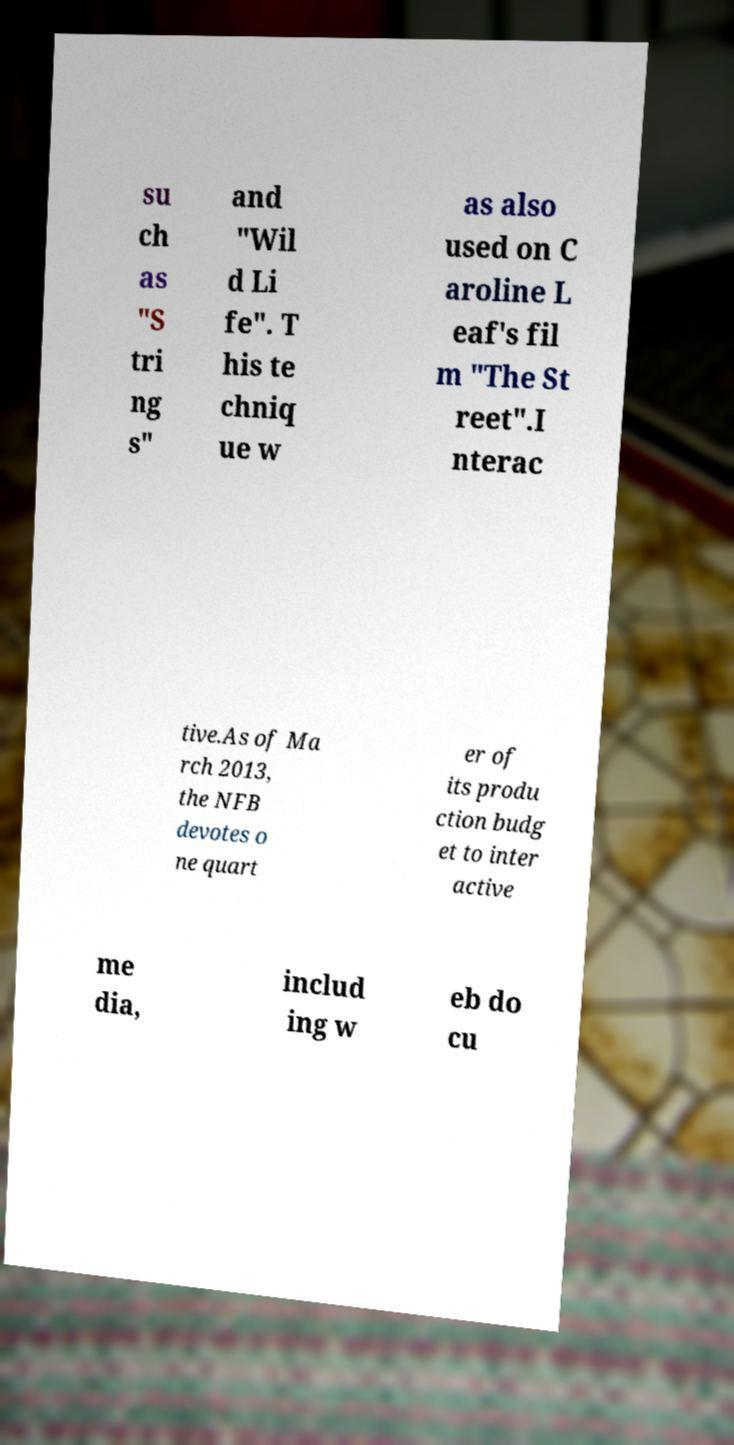Please read and relay the text visible in this image. What does it say? su ch as "S tri ng s" and "Wil d Li fe". T his te chniq ue w as also used on C aroline L eaf's fil m "The St reet".I nterac tive.As of Ma rch 2013, the NFB devotes o ne quart er of its produ ction budg et to inter active me dia, includ ing w eb do cu 